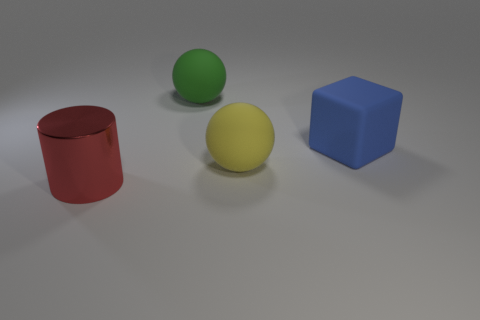There is a large thing to the left of the green rubber object; is it the same shape as the big green object?
Your answer should be very brief. No. What color is the metal cylinder?
Your answer should be compact. Red. Are any green rubber spheres visible?
Ensure brevity in your answer.  Yes. There is a sphere that is the same material as the large yellow object; what is its size?
Offer a terse response. Large. What is the shape of the large rubber object that is on the right side of the ball on the right side of the ball behind the block?
Offer a terse response. Cube. Is the number of big metallic things that are right of the large red metallic thing the same as the number of cylinders?
Make the answer very short. No. Do the large green thing and the blue thing have the same shape?
Offer a very short reply. No. What number of things are big metallic cylinders on the left side of the green sphere or big brown cubes?
Ensure brevity in your answer.  1. Are there the same number of big red objects that are in front of the large red metallic cylinder and blue rubber objects that are in front of the large yellow object?
Offer a terse response. Yes. What number of other things are there of the same shape as the large blue matte object?
Provide a short and direct response. 0. 